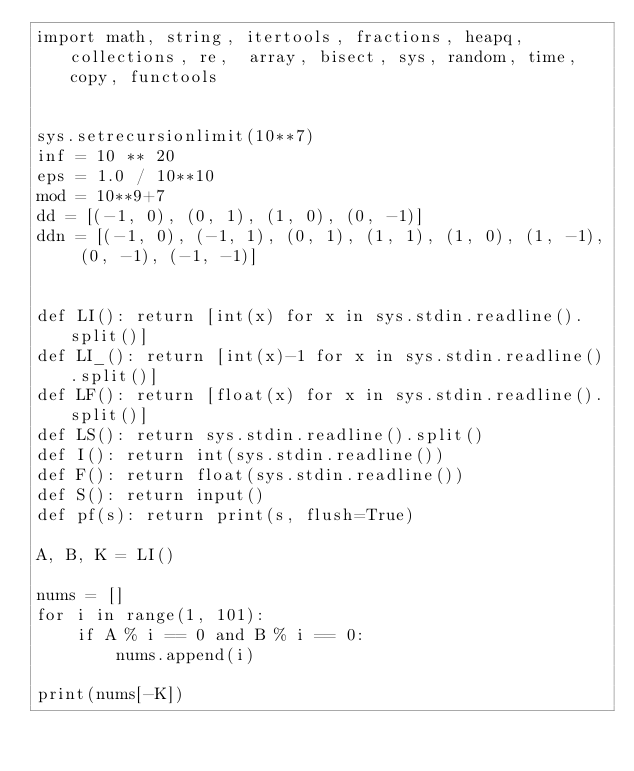<code> <loc_0><loc_0><loc_500><loc_500><_Python_>import math, string, itertools, fractions, heapq, collections, re,  array, bisect, sys, random, time, copy, functools


sys.setrecursionlimit(10**7)
inf = 10 ** 20
eps = 1.0 / 10**10
mod = 10**9+7
dd = [(-1, 0), (0, 1), (1, 0), (0, -1)]
ddn = [(-1, 0), (-1, 1), (0, 1), (1, 1), (1, 0), (1, -1), (0, -1), (-1, -1)]


def LI(): return [int(x) for x in sys.stdin.readline().split()]
def LI_(): return [int(x)-1 for x in sys.stdin.readline().split()]
def LF(): return [float(x) for x in sys.stdin.readline().split()]
def LS(): return sys.stdin.readline().split()
def I(): return int(sys.stdin.readline())
def F(): return float(sys.stdin.readline())
def S(): return input()
def pf(s): return print(s, flush=True)

A, B, K = LI()

nums = []
for i in range(1, 101):
    if A % i == 0 and B % i == 0:
        nums.append(i)

print(nums[-K])
</code> 